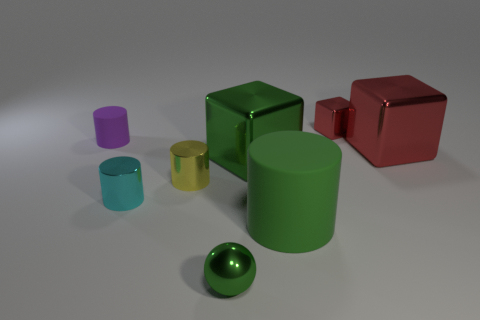Subtract 1 cylinders. How many cylinders are left? 3 Add 1 tiny cyan shiny things. How many objects exist? 9 Subtract all cubes. How many objects are left? 5 Subtract all tiny gray objects. Subtract all cylinders. How many objects are left? 4 Add 1 green blocks. How many green blocks are left? 2 Add 5 large brown matte balls. How many large brown matte balls exist? 5 Subtract 0 purple blocks. How many objects are left? 8 